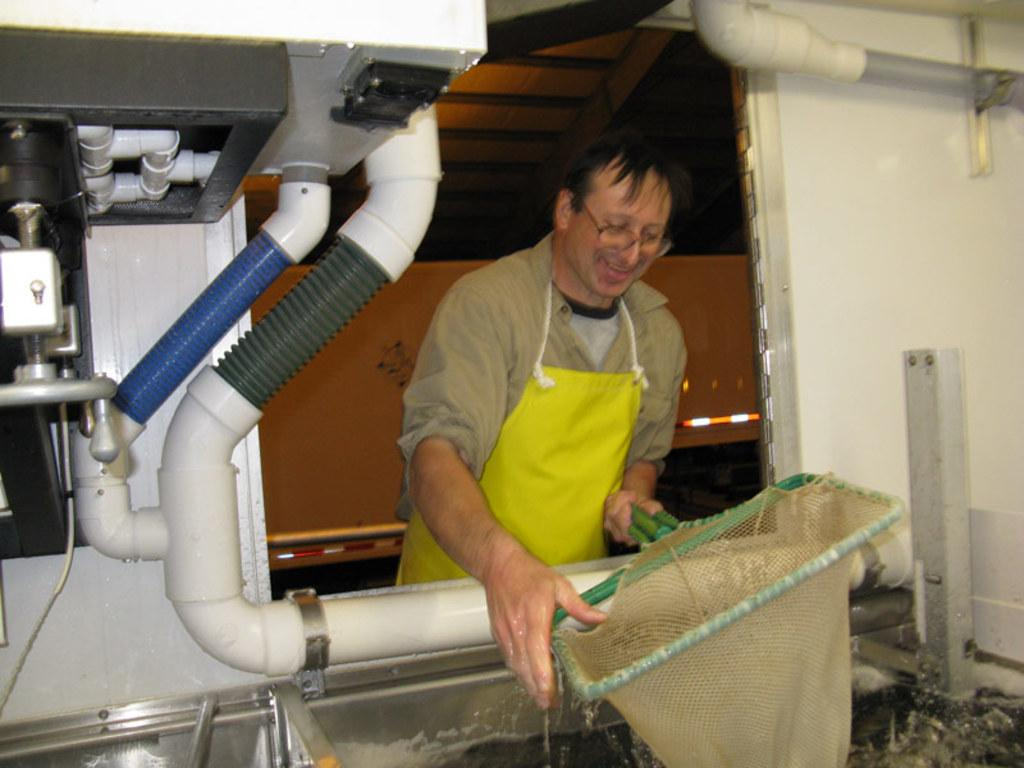What is the main subject of the image? There is a person in the image. What is the person wearing? The person is wearing an apron. What is the person holding in the image? The person is holding a basket. What is the person's facial expression? The person is smiling. What other object can be seen in the image? There is a machine in the image. Can you tell me how many beetles are crawling on the person's apron in the image? There are no beetles present on the person's apron in the image. What type of error is being corrected by the machine in the image? There is no indication of an error or any error-correcting function in the image; the machine's purpose is not specified. 